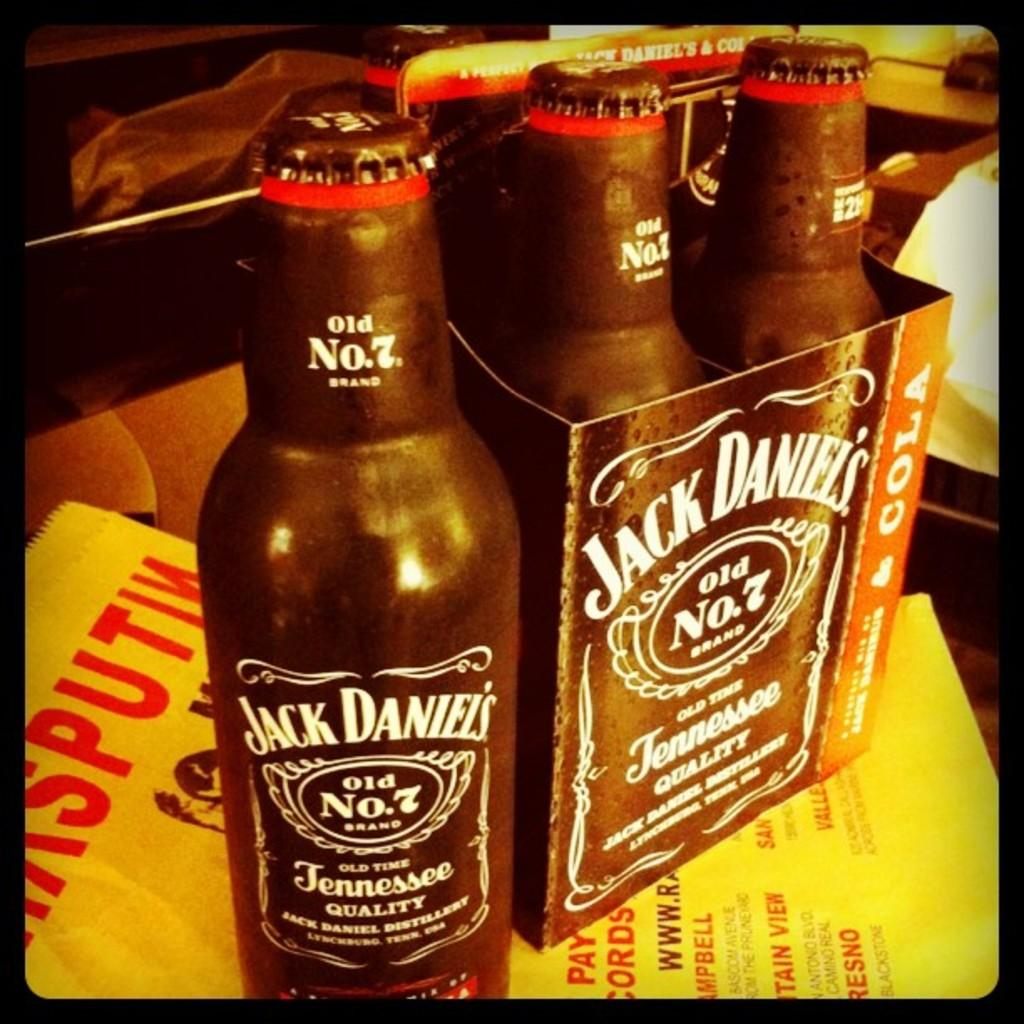<image>
Summarize the visual content of the image. A box of Jack Daniels alcohol on top of a table. 